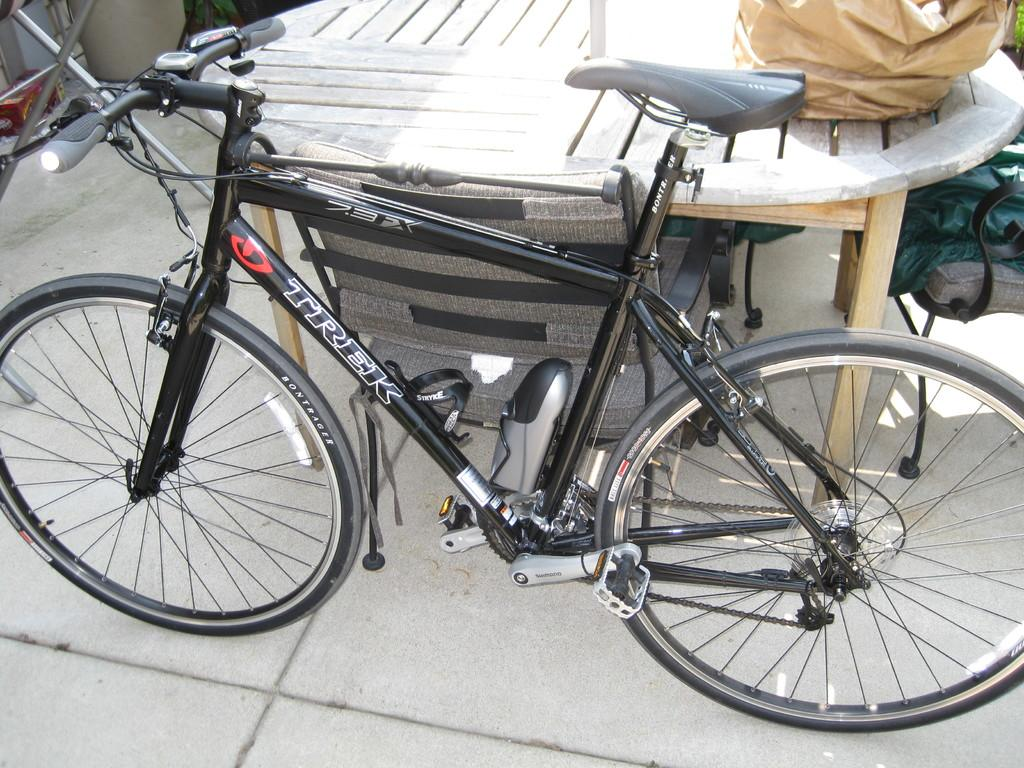What type of furniture is present in the image? There is a table in the image. Are there any chairs around the table? Yes, there are chairs around the table. What is parked beside the table? A bicycle is parked beside the table. What is placed on top of the table? There are covers on the table. Can you see any fairies dancing on the bicycle in the image? There are no fairies present in the image, and therefore no such activity can be observed. 